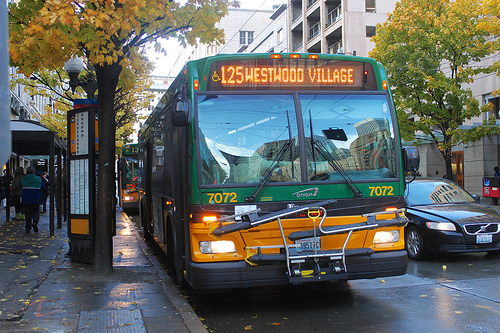What might be some reasons for the bus's prominent visibility in this environment? The bus's prominence in the image can be attributed to its vibrant, glossy black color that stands out against the lighter wet pavement, and its central positioning on the road ready to board passengers, emphasizing its role in daily commutes. 